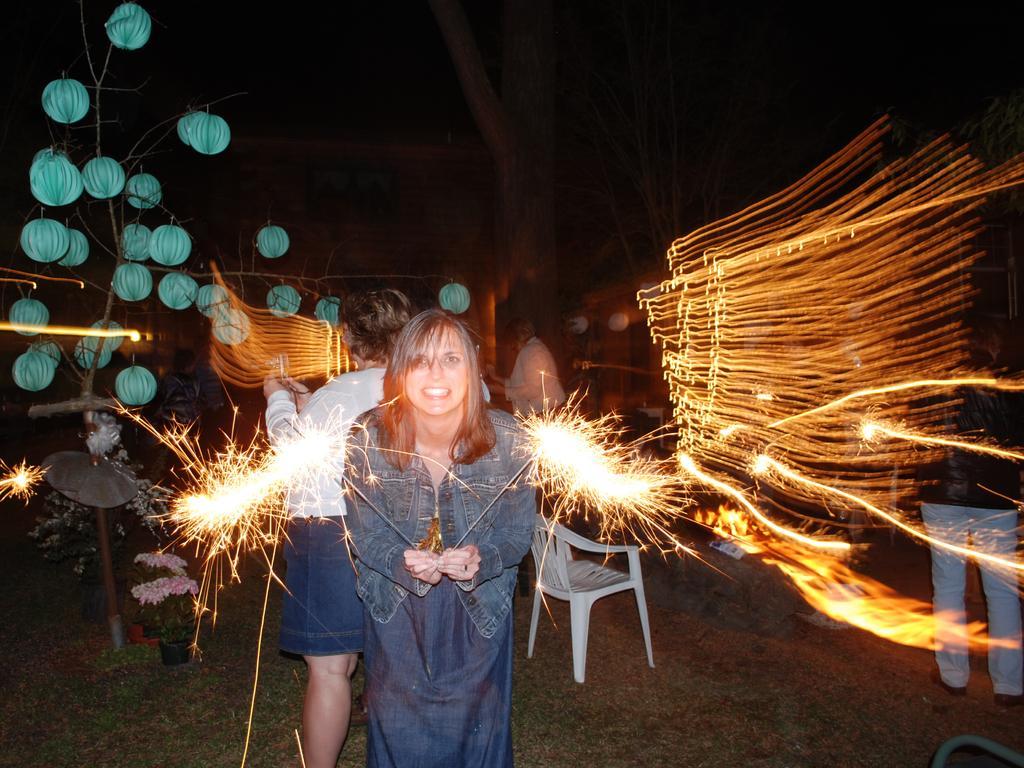Can you describe this image briefly? There is a woman holding crackers with her hands. Here we can see decorative balls, chair, lights, crackers, and two persons. There is a dark background and we can see trees. 